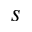Convert formula to latex. <formula><loc_0><loc_0><loc_500><loc_500>s</formula> 